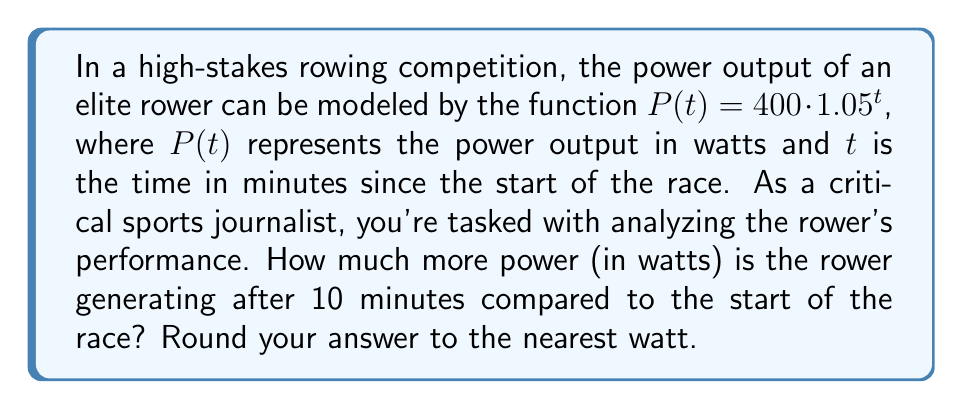Could you help me with this problem? To solve this problem, we need to follow these steps:

1) First, let's calculate the power output at the start of the race (t = 0):
   $P(0) = 400 \cdot 1.05^0 = 400$ watts

2) Now, let's calculate the power output after 10 minutes:
   $P(10) = 400 \cdot 1.05^{10}$

3) To evaluate $1.05^{10}$, we can use a calculator:
   $1.05^{10} \approx 1.6288946$

4) So, $P(10) = 400 \cdot 1.6288946 \approx 651.55784$ watts

5) To find how much more power the rower is generating, we subtract the initial power:
   $651.55784 - 400 = 251.55784$ watts

6) Rounding to the nearest watt:
   $251.55784 \approx 252$ watts

This exponential model dramatically illustrates the intensity of elite rowing, showing how power output can increase significantly over a relatively short time, adding depth to what could otherwise be a dry statistical report.
Answer: 252 watts 